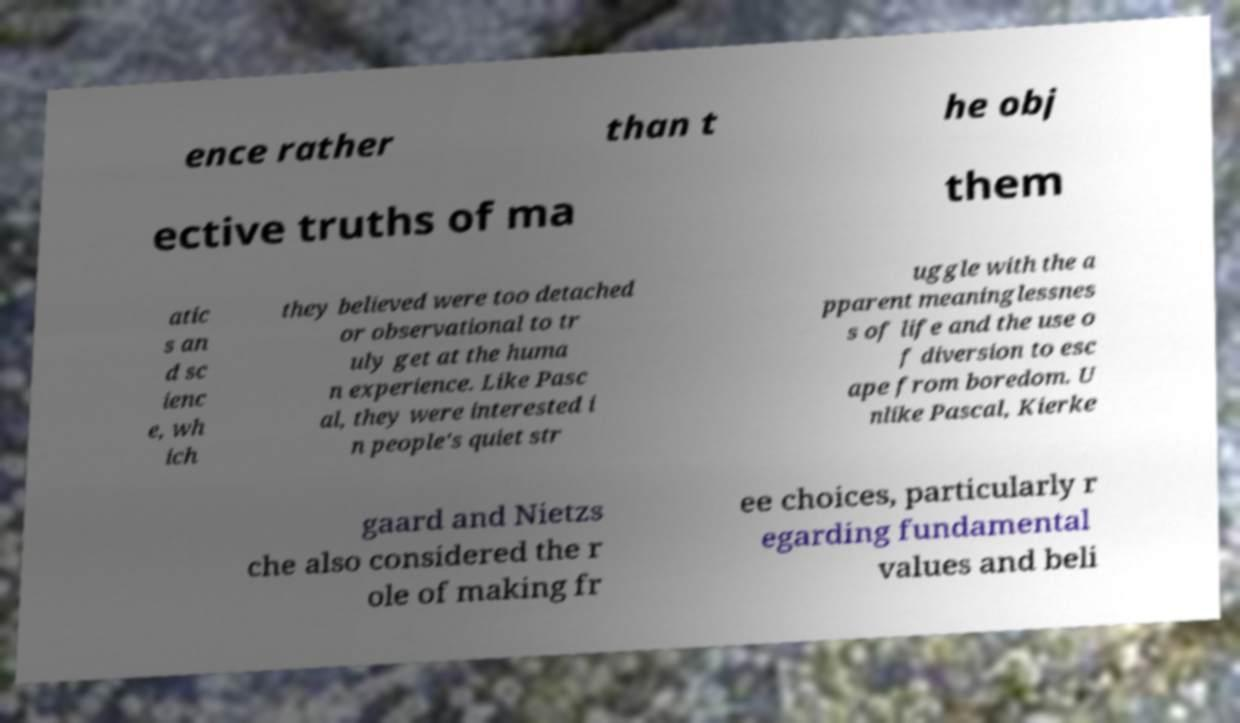Could you assist in decoding the text presented in this image and type it out clearly? ence rather than t he obj ective truths of ma them atic s an d sc ienc e, wh ich they believed were too detached or observational to tr uly get at the huma n experience. Like Pasc al, they were interested i n people's quiet str uggle with the a pparent meaninglessnes s of life and the use o f diversion to esc ape from boredom. U nlike Pascal, Kierke gaard and Nietzs che also considered the r ole of making fr ee choices, particularly r egarding fundamental values and beli 